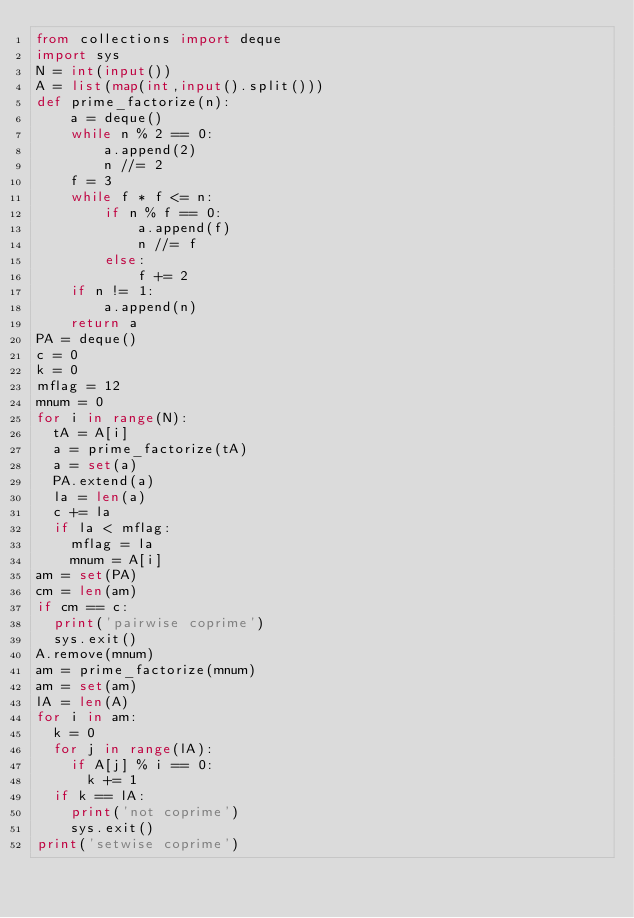<code> <loc_0><loc_0><loc_500><loc_500><_Python_>from collections import deque
import sys
N = int(input())
A = list(map(int,input().split()))
def prime_factorize(n):
    a = deque()
    while n % 2 == 0:
        a.append(2)
        n //= 2
    f = 3
    while f * f <= n:
        if n % f == 0:
            a.append(f)
            n //= f
        else:
            f += 2
    if n != 1:
        a.append(n)
    return a
PA = deque()
c = 0
k = 0
mflag = 12
mnum = 0
for i in range(N):
  tA = A[i]
  a = prime_factorize(tA)
  a = set(a)
  PA.extend(a)
  la = len(a)
  c += la
  if la < mflag:
    mflag = la
    mnum = A[i]
am = set(PA)
cm = len(am)
if cm == c:
  print('pairwise coprime')
  sys.exit()
A.remove(mnum)  
am = prime_factorize(mnum)
am = set(am)
lA = len(A)
for i in am:
  k = 0
  for j in range(lA):
    if A[j] % i == 0:
      k += 1
  if k == lA:
    print('not coprime')
    sys.exit()
print('setwise coprime')  </code> 